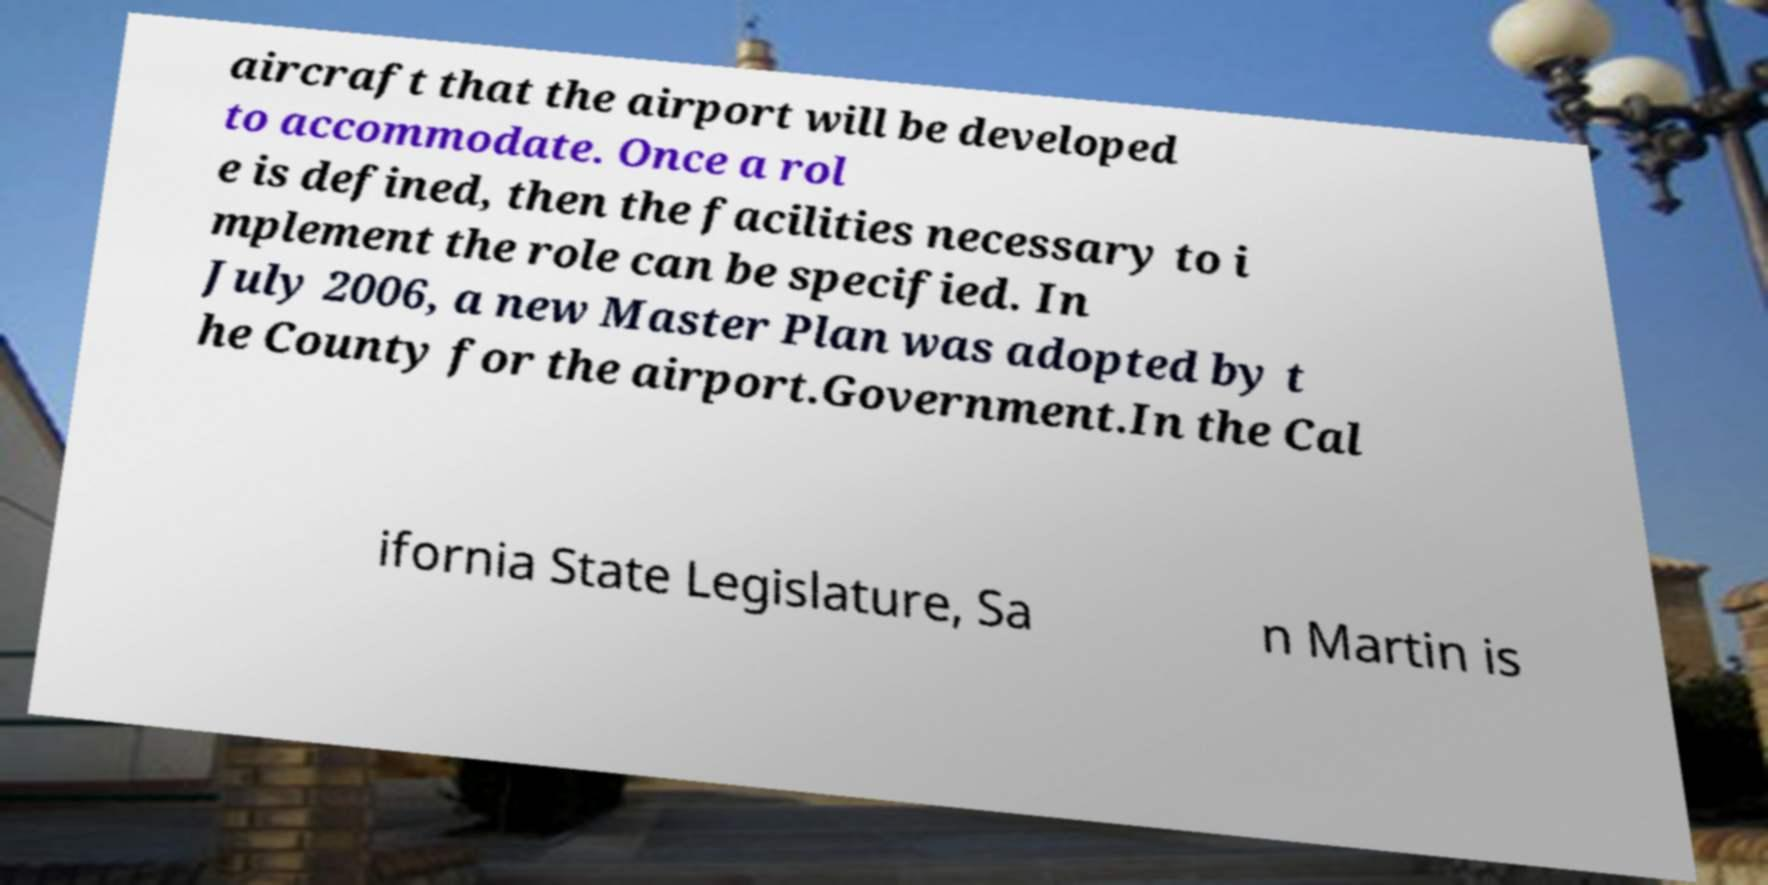What messages or text are displayed in this image? I need them in a readable, typed format. aircraft that the airport will be developed to accommodate. Once a rol e is defined, then the facilities necessary to i mplement the role can be specified. In July 2006, a new Master Plan was adopted by t he County for the airport.Government.In the Cal ifornia State Legislature, Sa n Martin is 